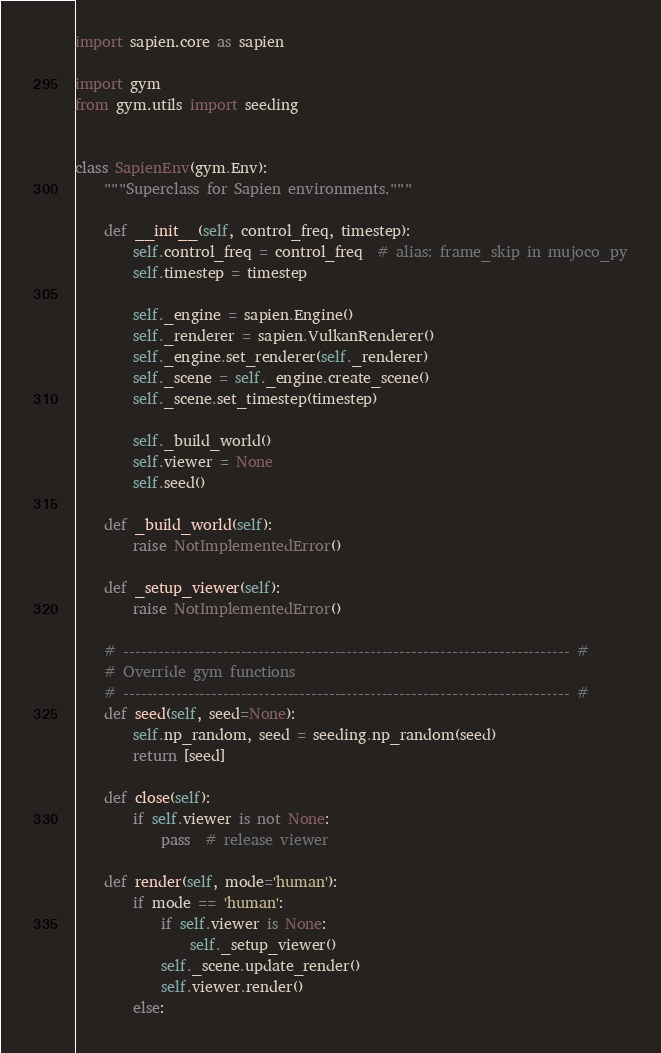Convert code to text. <code><loc_0><loc_0><loc_500><loc_500><_Python_>import sapien.core as sapien

import gym
from gym.utils import seeding


class SapienEnv(gym.Env):
    """Superclass for Sapien environments."""

    def __init__(self, control_freq, timestep):
        self.control_freq = control_freq  # alias: frame_skip in mujoco_py
        self.timestep = timestep

        self._engine = sapien.Engine()
        self._renderer = sapien.VulkanRenderer()
        self._engine.set_renderer(self._renderer)
        self._scene = self._engine.create_scene()
        self._scene.set_timestep(timestep)

        self._build_world()
        self.viewer = None
        self.seed()

    def _build_world(self):
        raise NotImplementedError()

    def _setup_viewer(self):
        raise NotImplementedError()

    # ---------------------------------------------------------------------------- #
    # Override gym functions
    # ---------------------------------------------------------------------------- #
    def seed(self, seed=None):
        self.np_random, seed = seeding.np_random(seed)
        return [seed]

    def close(self):
        if self.viewer is not None:
            pass  # release viewer

    def render(self, mode='human'):
        if mode == 'human':
            if self.viewer is None:
                self._setup_viewer()
            self._scene.update_render()
            self.viewer.render()
        else:</code> 